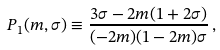Convert formula to latex. <formula><loc_0><loc_0><loc_500><loc_500>P _ { 1 } ( m , \sigma ) \equiv \frac { 3 \sigma - 2 m ( 1 + 2 \sigma ) } { ( - 2 m ) ( 1 - 2 m ) \sigma } \, ,</formula> 